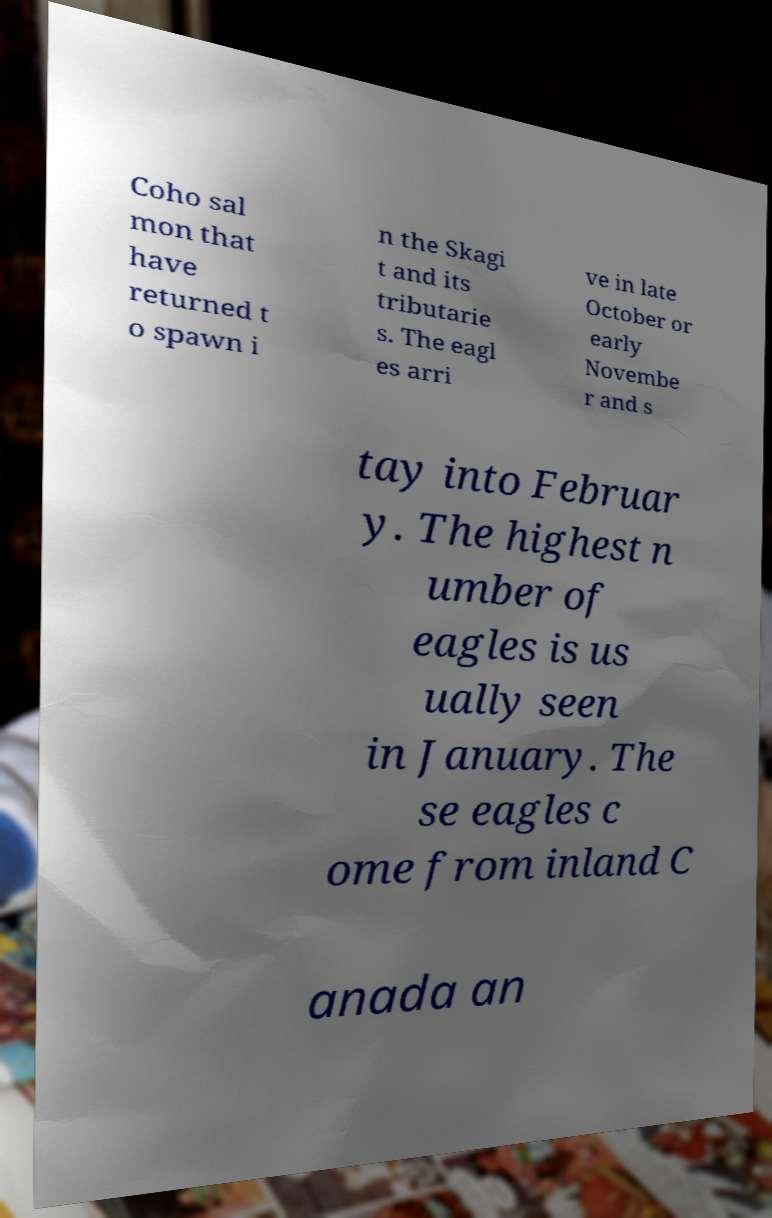Could you extract and type out the text from this image? Coho sal mon that have returned t o spawn i n the Skagi t and its tributarie s. The eagl es arri ve in late October or early Novembe r and s tay into Februar y. The highest n umber of eagles is us ually seen in January. The se eagles c ome from inland C anada an 